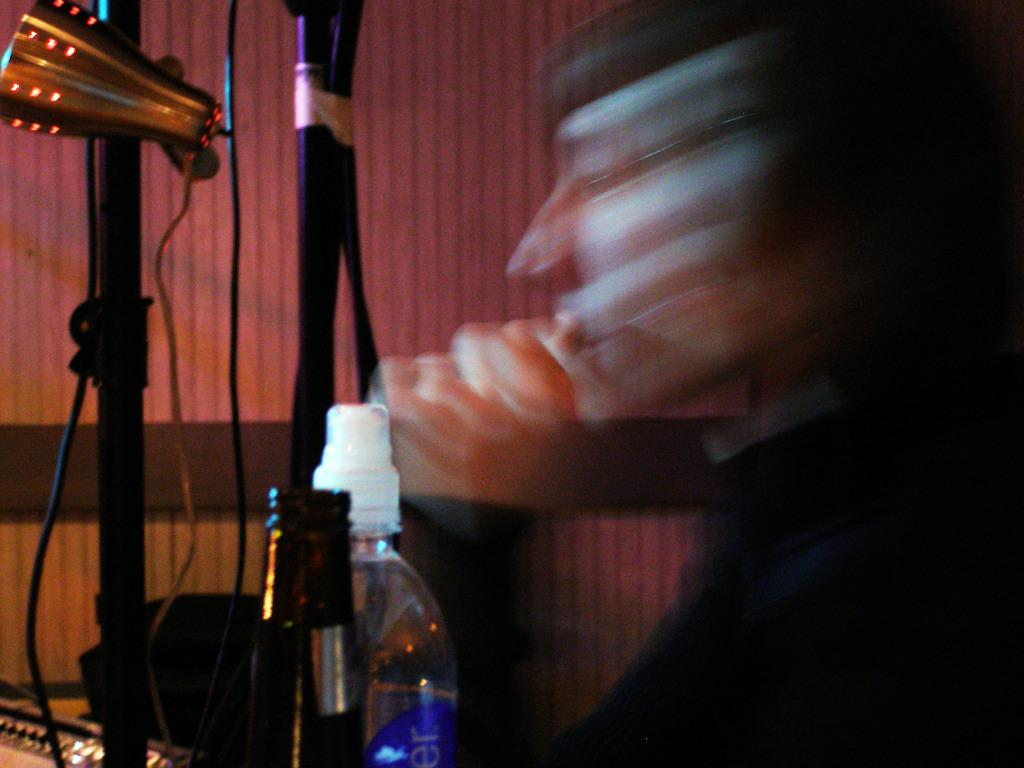What objects are located at the bottom of the image? There are bottles and poles with wires at the bottom of the image. What can be seen behind the poles and wires? There is a wall visible behind the poles and wires. How would you describe the quality of the right side of the image? The right side of the image is blurry. What advice does the uncle give in the image? There is no uncle present in the image, so no advice can be given. What type of fan is visible in the image? There is no fan present in the image. 